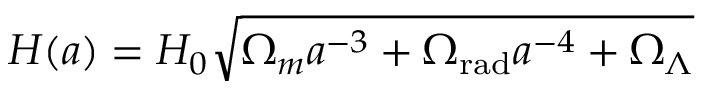<formula> <loc_0><loc_0><loc_500><loc_500>H ( a ) = H _ { 0 } { \sqrt { \Omega _ { m } a ^ { - 3 } + \Omega _ { r a d } a ^ { - 4 } + \Omega _ { \Lambda } } }</formula> 